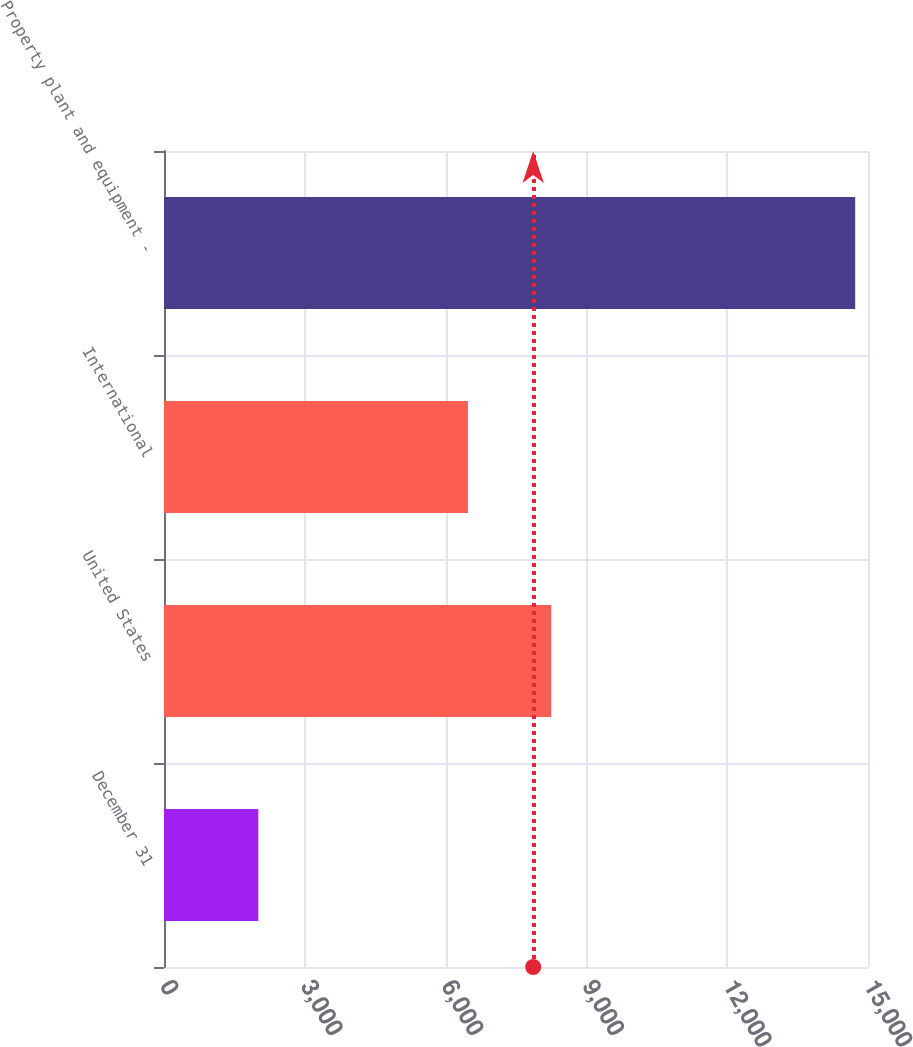<chart> <loc_0><loc_0><loc_500><loc_500><bar_chart><fcel>December 31<fcel>United States<fcel>International<fcel>Property plant and equipment -<nl><fcel>2010<fcel>8251<fcel>6476<fcel>14727<nl></chart> 